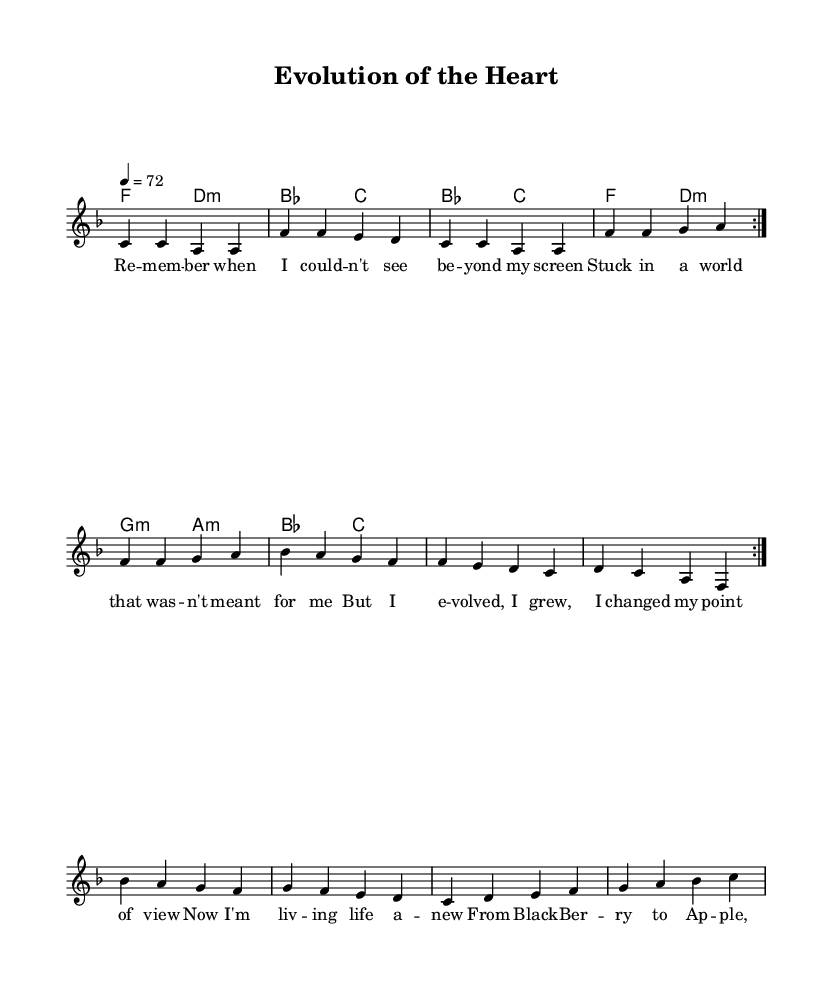What is the key signature of this music? The key signature features one flat, which indicates it is in F major, as only B flat is present.
Answer: F major What is the time signature of this piece? The time signature shown at the beginning of the score is 4/4, meaning there are four beats in each measure.
Answer: 4/4 What is the tempo marking of the piece? The tempo marking indicates a speed of 72 beats per minute, which is noted at the start of the score with "4 = 72."
Answer: 72 How many times is the first section repeated? The first section, marked with "\repeat volta 2," specifies that it is to be played two times before moving on.
Answer: 2 What type of mood is reflected in the lyrics? The lyrics convey a sense of personal growth and reflection, with phrases emphasizing evolution and change in perspective.
Answer: Growth What primary emotions do the lyrics convey? The lyrics express feelings of transformation and empowerment, focusing on moving forward from past experiences.
Answer: Empowerment What is the significance of the transition mentioned in the bridge? The bridge contrasts the speaker's past experiences with BlackBerry to their current experiences with Apple, symbolizing personal growth and adaptation.
Answer: Personal growth 